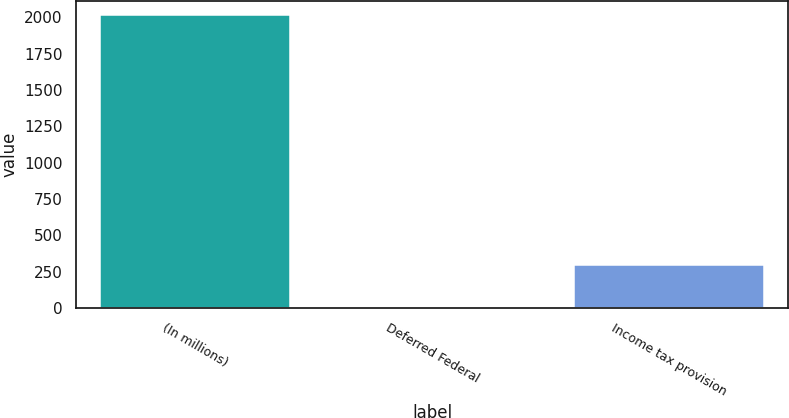Convert chart. <chart><loc_0><loc_0><loc_500><loc_500><bar_chart><fcel>(In millions)<fcel>Deferred Federal<fcel>Income tax provision<nl><fcel>2012<fcel>3<fcel>300<nl></chart> 